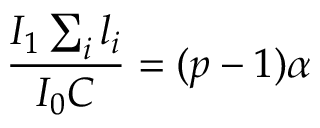<formula> <loc_0><loc_0><loc_500><loc_500>\frac { I _ { 1 } \sum _ { i } l _ { i } } { I _ { 0 } C } = ( p - 1 ) \alpha</formula> 